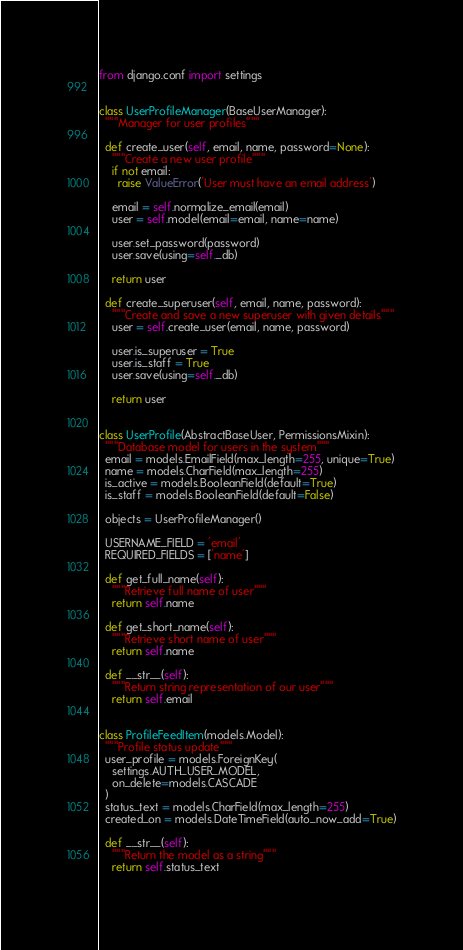Convert code to text. <code><loc_0><loc_0><loc_500><loc_500><_Python_>from django.conf import settings


class UserProfileManager(BaseUserManager):
  """Manager for user profiles"""

  def create_user(self, email, name, password=None):
    """Create a new user profile"""
    if not email:
      raise ValueError('User must have an email address')

    email = self.normalize_email(email)
    user = self.model(email=email, name=name)

    user.set_password(password)
    user.save(using=self._db)

    return user

  def create_superuser(self, email, name, password):
    """Create and save a new superuser with given details"""
    user = self.create_user(email, name, password)

    user.is_superuser = True
    user.is_staff = True
    user.save(using=self._db)

    return user


class UserProfile(AbstractBaseUser, PermissionsMixin):
  """Database model for users in the system"""
  email = models.EmailField(max_length=255, unique=True)
  name = models.CharField(max_length=255)
  is_active = models.BooleanField(default=True)
  is_staff = models.BooleanField(default=False)

  objects = UserProfileManager()

  USERNAME_FIELD = 'email'
  REQUIRED_FIELDS = ['name']

  def get_full_name(self):
    """Retrieve full name of user"""
    return self.name

  def get_short_name(self):
    """Retrieve short name of user"""
    return self.name

  def __str__(self):
    """Return string representation of our user"""
    return self.email


class ProfileFeedItem(models.Model):
  """Profile status update"""
  user_profile = models.ForeignKey(
    settings.AUTH_USER_MODEL,
    on_delete=models.CASCADE
  )
  status_text = models.CharField(max_length=255)
  created_on = models.DateTimeField(auto_now_add=True)

  def __str__(self):
    """Return the model as a string"""
    return self.status_text
    </code> 